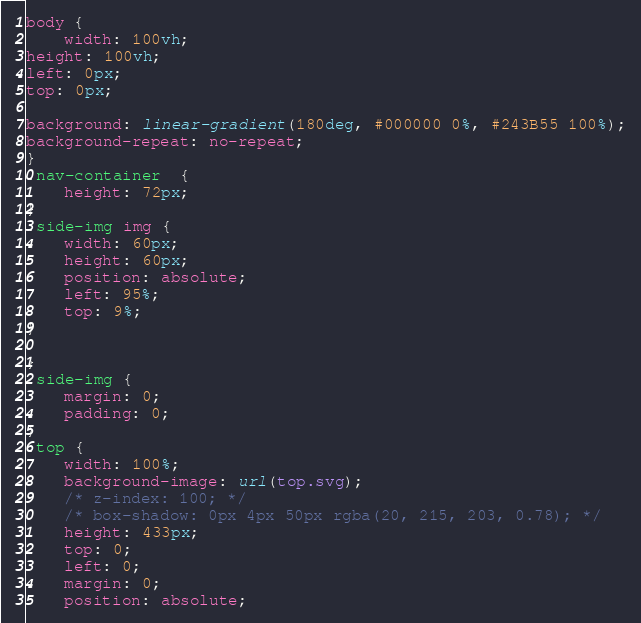<code> <loc_0><loc_0><loc_500><loc_500><_CSS_>body {
    width: 100vh;
height: 100vh;
left: 0px;
top: 0px;

background: linear-gradient(180deg, #000000 0%, #243B55 100%);
background-repeat: no-repeat;
}
.nav-container  {
    height: 72px;
}
.side-img img {
    width: 60px;
    height: 60px;
    position: absolute;
    left: 95%;
    top: 9%;
}
    
}
.side-img {
    margin: 0;
    padding: 0;
}
.top {
    width: 100%;
    background-image: url(top.svg);
    /* z-index: 100; */
    /* box-shadow: 0px 4px 50px rgba(20, 215, 203, 0.78); */
    height: 433px;
    top: 0;
    left: 0;
    margin: 0;
    position: absolute;</code> 